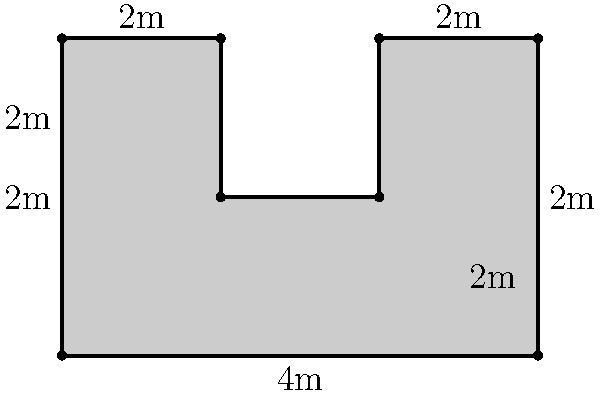Yo, check it! You're planning a sick graffiti mural for your next hip-hop event. The wall has some irregular shapes, as shown in the diagram. What's the perimeter of this dope mural space in meters? Let's break it down step by step:

1) Start from the bottom left corner and move clockwise:
   
   - Bottom edge: $4m + 2m = 6m$
   - Right edge: $2m + 2m = 4m$
   - Top edge: $2m + 2m + 2m = 6m$
   - Left edge: $4m$

2) Now, we need to add the internal edges:
   
   - Left internal vertical edge: $2m$
   - Right internal vertical edge: $2m$

3) Sum up all these lengths:

   $$(6m + 4m + 6m + 4m) + (2m + 2m) = 20m + 4m = 24m$$

Therefore, the total perimeter of the mural space is $24$ meters.
Answer: $24m$ 